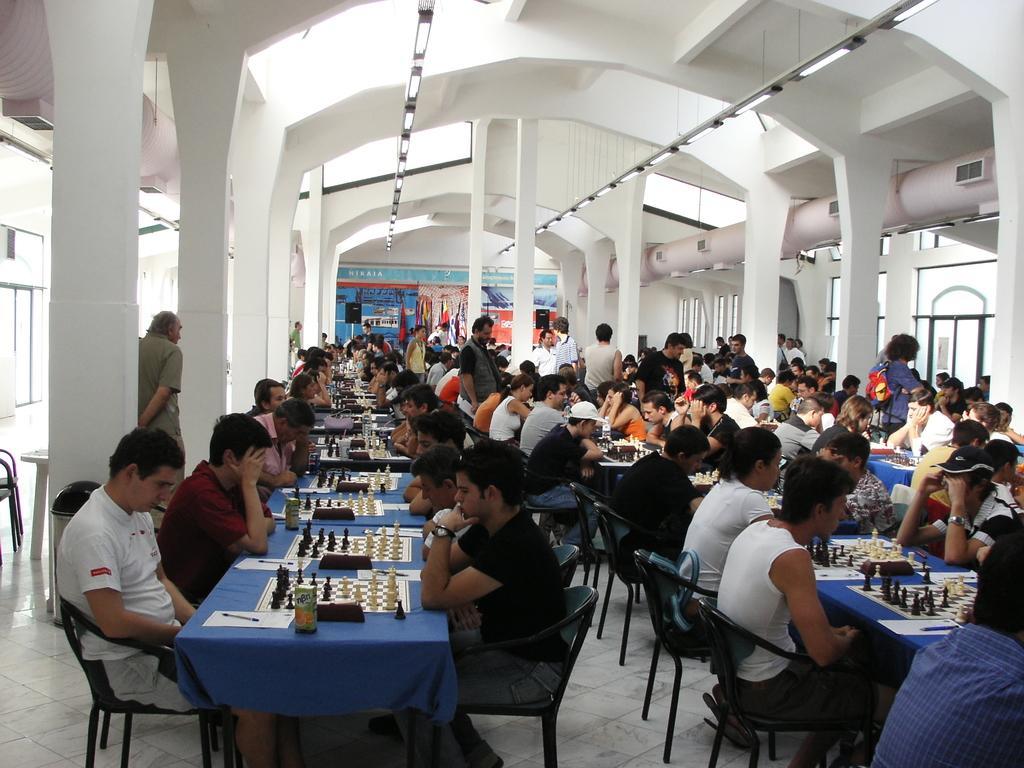Please provide a concise description of this image. In this picture there are many people sitting on the chair. In front of them there is a table with blue cloth on it. On the table there are chess board, chess coins, juice bottle, paper, pen and clock. To the right and left side there are pillars and windows on the both sides. In the background there are posters. And on the top there are lights. 